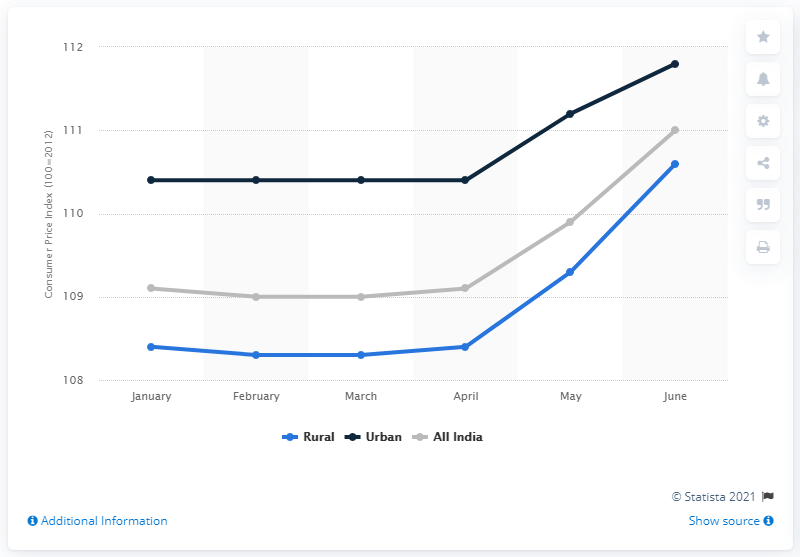Mention a couple of crucial points in this snapshot. In June 2019, the Consumer Price Index for sugar and confectionery was 110.6. 